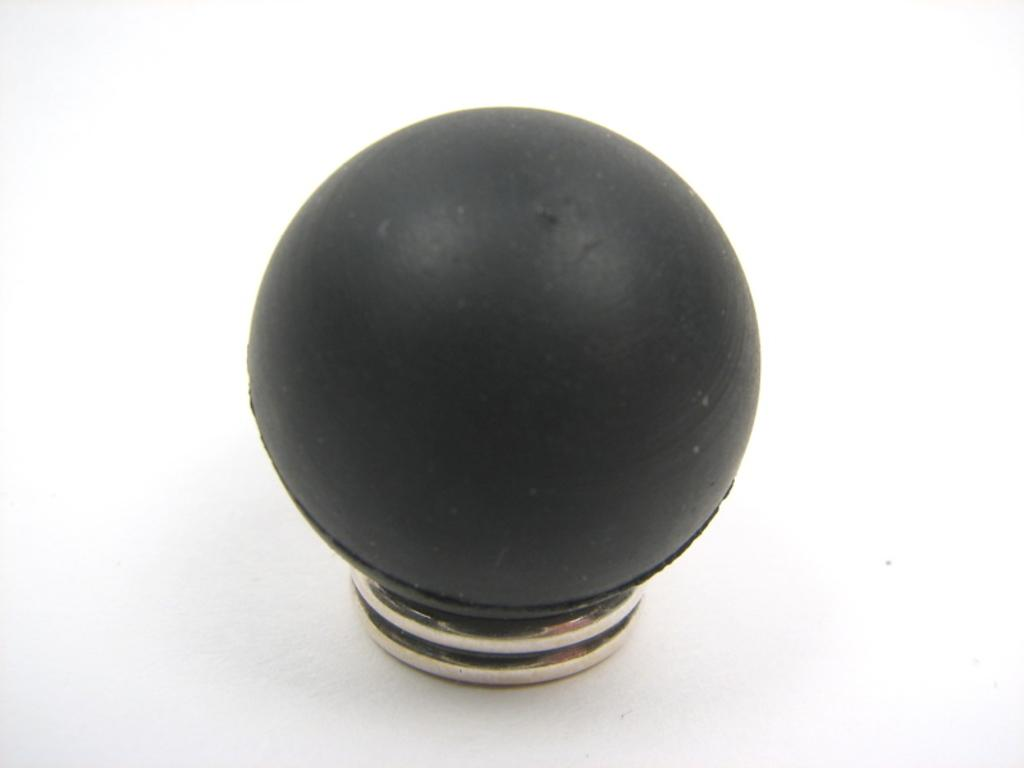What can be seen in the image? There is an object in the image. What is the color of the object? The object is black in color. How does the turkey lift the object in the image? There is no turkey present in the image, and therefore no such interaction can be observed. 